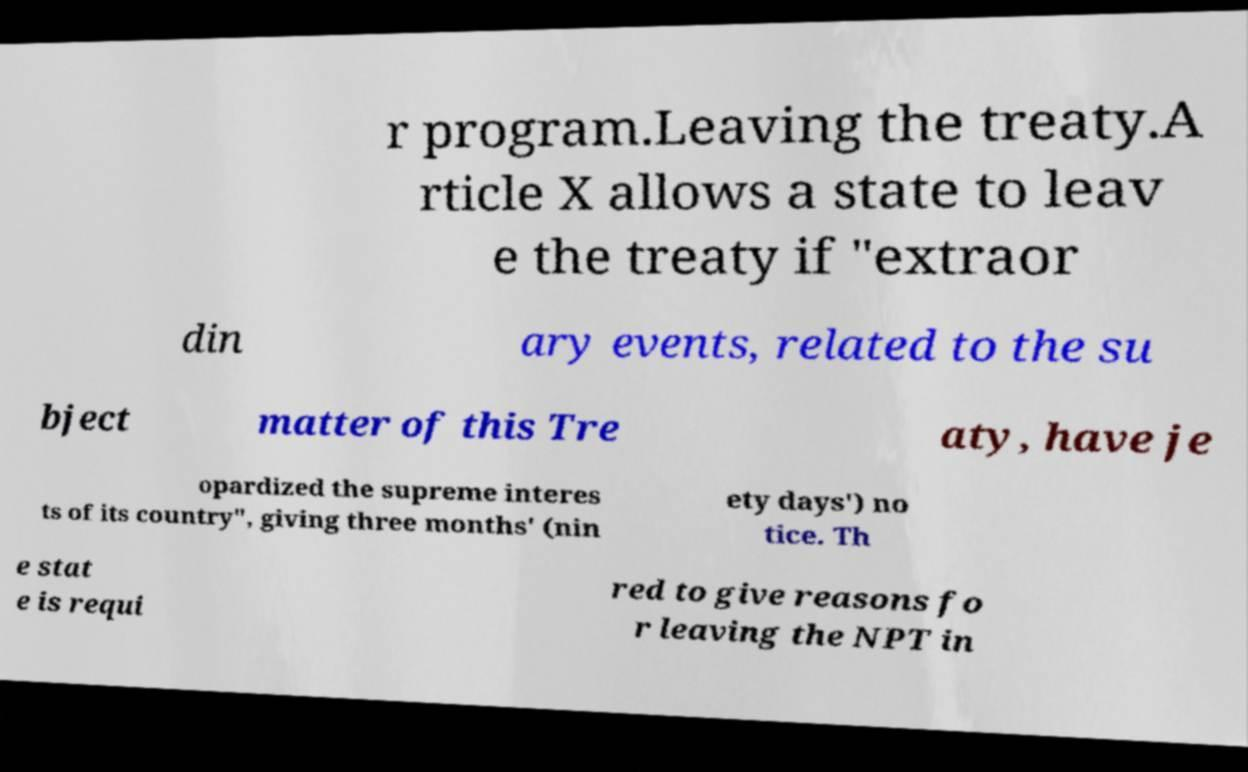Can you accurately transcribe the text from the provided image for me? r program.Leaving the treaty.A rticle X allows a state to leav e the treaty if "extraor din ary events, related to the su bject matter of this Tre aty, have je opardized the supreme interes ts of its country", giving three months' (nin ety days') no tice. Th e stat e is requi red to give reasons fo r leaving the NPT in 